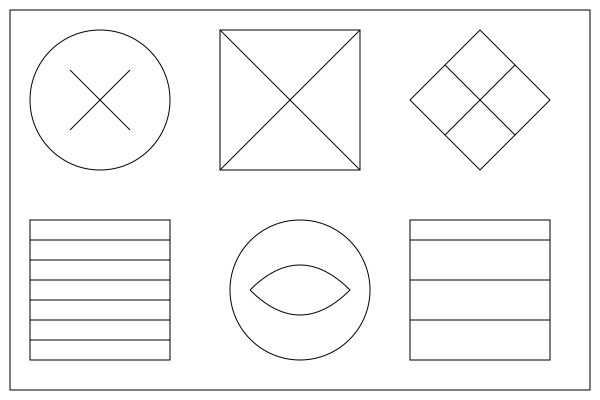As an artist inspired by sustainable architecture, identify the sketch that represents rammed earth construction, a technique known for its low environmental impact and thermal mass properties. To identify the sketch representing rammed earth construction, let's analyze each sketch:

1. Top-left: Circular sketch with crossed lines, likely representing bamboo.
2. Top-center: Square sketch with diagonal lines, possibly depicting recycled steel.
3. Top-right: Diamond-shaped sketch with crossed lines, potentially illustrating reclaimed wood.
4. Bottom-left: Rectangular sketch with multiple horizontal lines. This is characteristic of rammed earth construction, where layers of earth are compacted to form walls.
5. Bottom-center: Circular sketch with a curved line, possibly representing cork.
6. Bottom-right: Rectangular sketch with fewer, more widely spaced horizontal lines, likely representing straw bale construction.

The sketch that best represents rammed earth construction is the bottom-left image. Rammed earth walls are built by compacting layers of earth mixture between forms, resulting in a distinctive layered appearance. This technique is known for its sustainability, as it uses locally available materials and provides excellent thermal mass for energy efficiency.
Answer: Bottom-left sketch 